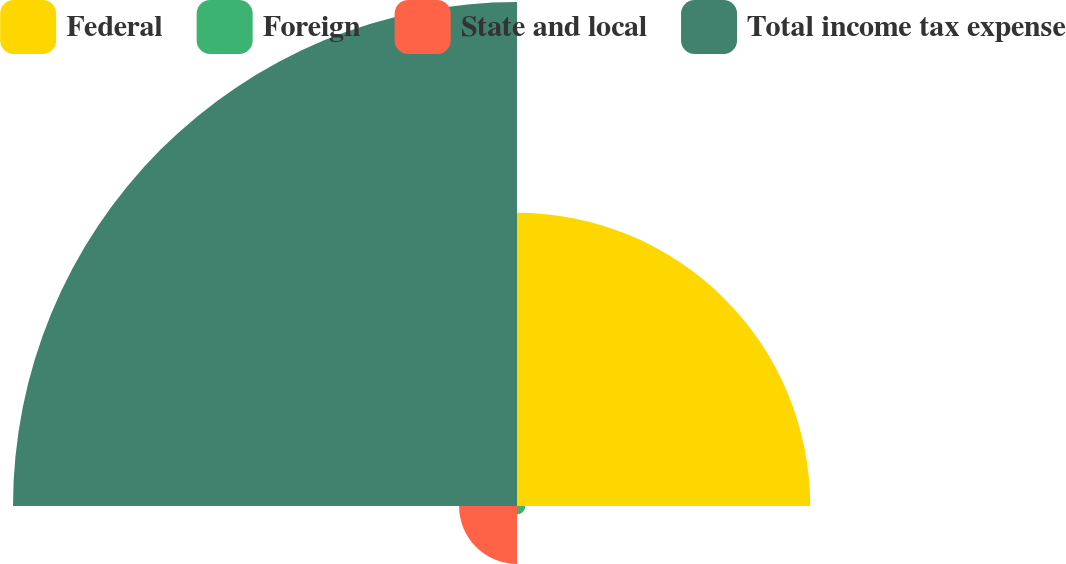Convert chart to OTSL. <chart><loc_0><loc_0><loc_500><loc_500><pie_chart><fcel>Federal<fcel>Foreign<fcel>State and local<fcel>Total income tax expense<nl><fcel>33.96%<fcel>0.97%<fcel>6.71%<fcel>58.37%<nl></chart> 